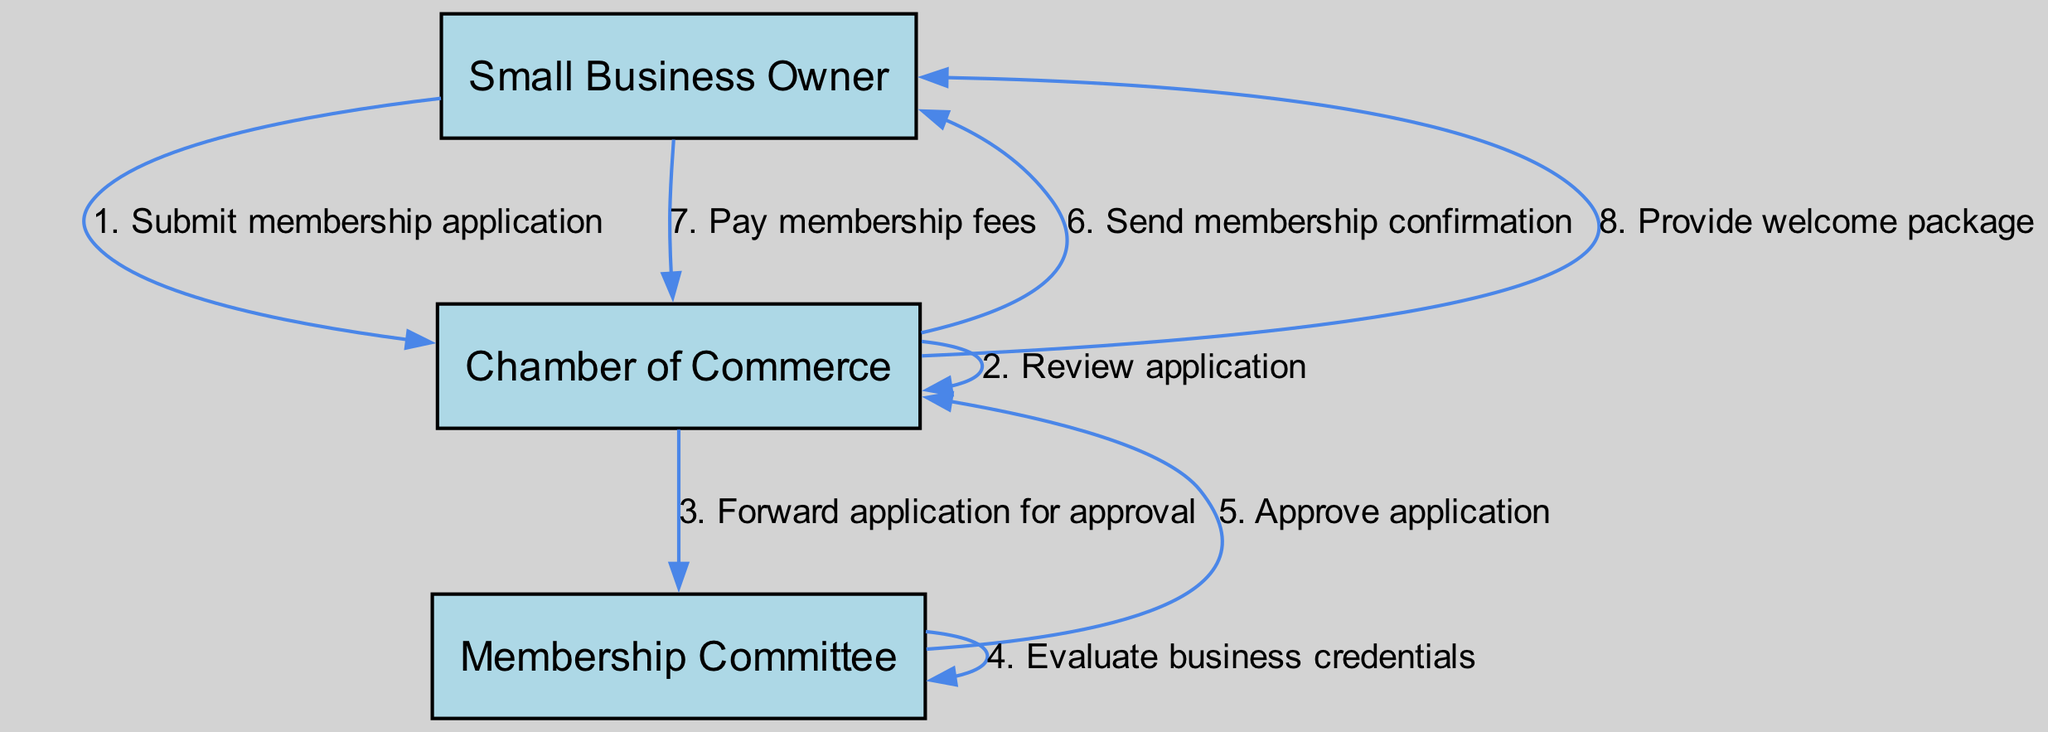What is the first action taken by the Small Business Owner? The diagram indicates that the first action taken by the Small Business Owner is to submit a membership application to the Chamber of Commerce. This is the first step in the sequence, reflecting the initiation of the membership process.
Answer: Submit membership application How many actors are depicted in the diagram? The diagram shows three distinct actors involved in the membership application process: Small Business Owner, Chamber of Commerce, and Membership Committee. Counting these actors provides the total number involved.
Answer: 3 Which actor sends the membership confirmation? According to the flow of the diagram, the Chamber of Commerce is responsible for sending the membership confirmation to the Small Business Owner after the application is approved. This identifies the specific role of the Chamber during the confirmation stage.
Answer: Chamber of Commerce What step follows after the Membership Committee approves the application? Following the approval by the Membership Committee, the next action taken is for the Chamber of Commerce to send a membership confirmation to the Small Business Owner. This indicates the direct follow-up to the committee's decision.
Answer: Send membership confirmation What is the last action that occurs in the process? The last action detailed in the diagram is that the Chamber of Commerce provides a welcome package to the Small Business Owner. This action signifies the completion of the membership process and the initiation of the business’s relationship with the Chamber.
Answer: Provide welcome package What action takes place after the Small Business Owner pays membership fees? According to the sequence, the action that follows the Small Business Owner paying the membership fees is that the Chamber of Commerce provides a welcome package. This demonstrates the direct correlation between payment and the subsequent administrative action.
Answer: Provide welcome package How does the Chamber of Commerce evaluate the application? The application is evaluated by the Membership Committee, which assesses the business credentials. This indicates that while the Chamber has an overarching role, the specific evaluation process is assigned to the committee.
Answer: Evaluate business credentials What message does the Chamber of Commerce send after reviewing the application? After reviewing the application, the Chamber of Commerce forwards it to the Membership Committee for approval. This step indicates the transition of responsibility for the approval process from the Chamber to the committee.
Answer: Forward application for approval 